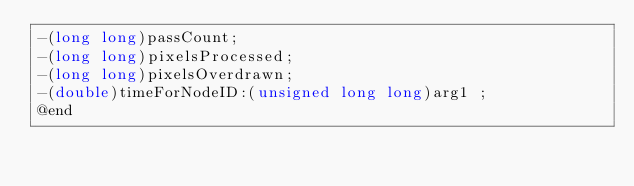<code> <loc_0><loc_0><loc_500><loc_500><_C_>-(long long)passCount;
-(long long)pixelsProcessed;
-(long long)pixelsOverdrawn;
-(double)timeForNodeID:(unsigned long long)arg1 ;
@end

</code> 